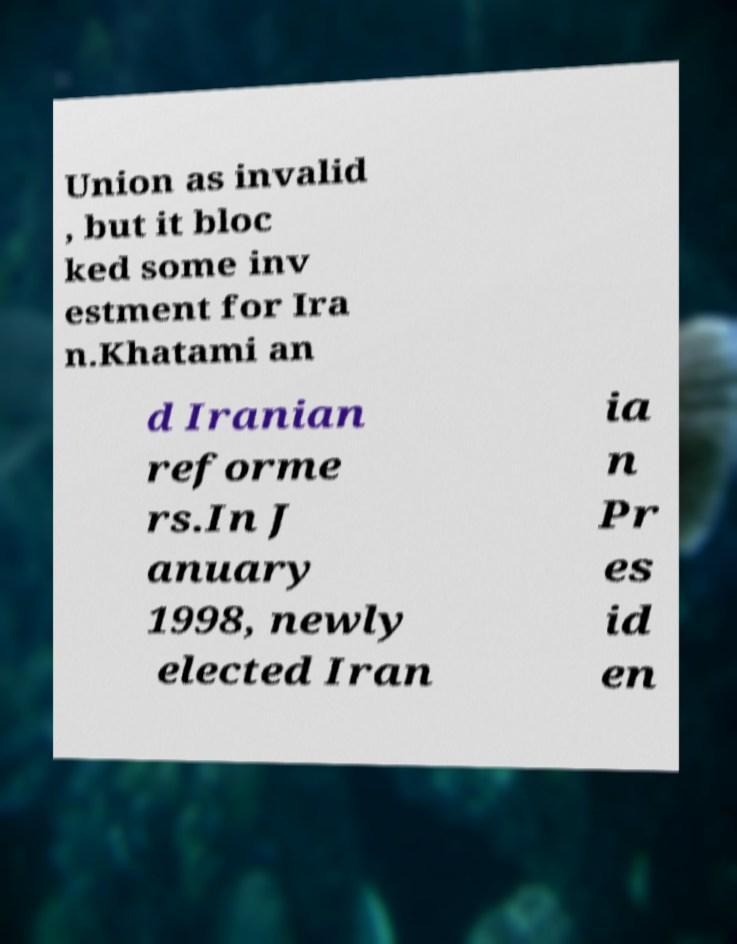I need the written content from this picture converted into text. Can you do that? Union as invalid , but it bloc ked some inv estment for Ira n.Khatami an d Iranian reforme rs.In J anuary 1998, newly elected Iran ia n Pr es id en 